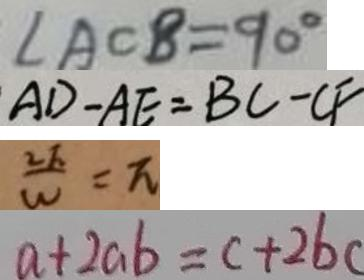Convert formula to latex. <formula><loc_0><loc_0><loc_500><loc_500>\angle A C B = 9 0 ^ { \circ } 
 A D - A E = B C - C F 
 \frac { 2 F } { W } = \pi 
 a + 2 a b = c + 2 b c</formula> 